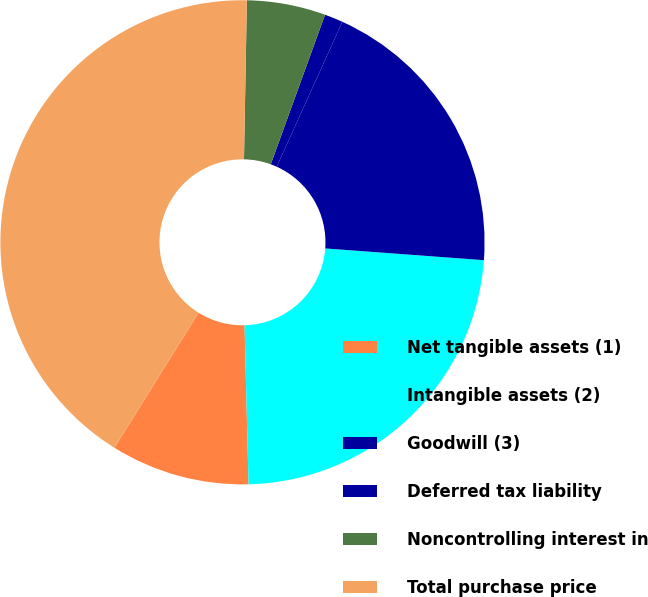Convert chart. <chart><loc_0><loc_0><loc_500><loc_500><pie_chart><fcel>Net tangible assets (1)<fcel>Intangible assets (2)<fcel>Goodwill (3)<fcel>Deferred tax liability<fcel>Noncontrolling interest in<fcel>Total purchase price<nl><fcel>9.27%<fcel>23.43%<fcel>19.41%<fcel>1.23%<fcel>5.25%<fcel>41.43%<nl></chart> 